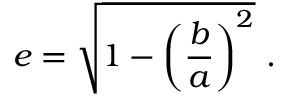<formula> <loc_0><loc_0><loc_500><loc_500>e = { \sqrt { 1 - \left ( { \frac { b } { a } } \right ) ^ { 2 } } } \ .</formula> 